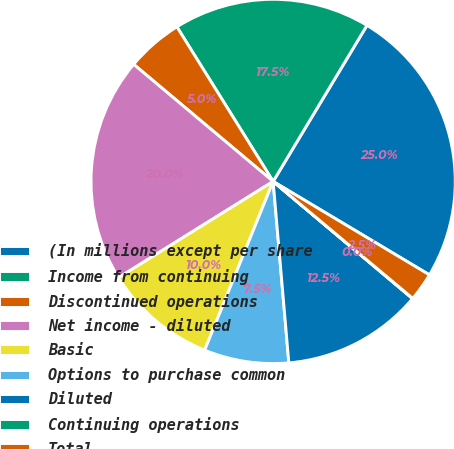Convert chart. <chart><loc_0><loc_0><loc_500><loc_500><pie_chart><fcel>(In millions except per share<fcel>Income from continuing<fcel>Discontinued operations<fcel>Net income - diluted<fcel>Basic<fcel>Options to purchase common<fcel>Diluted<fcel>Continuing operations<fcel>Total<nl><fcel>24.96%<fcel>17.48%<fcel>5.02%<fcel>19.98%<fcel>10.0%<fcel>7.51%<fcel>12.5%<fcel>0.03%<fcel>2.52%<nl></chart> 